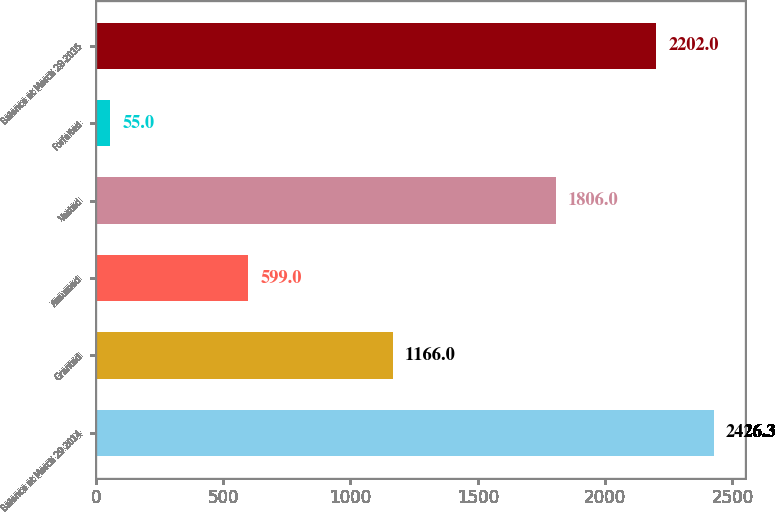Convert chart to OTSL. <chart><loc_0><loc_0><loc_500><loc_500><bar_chart><fcel>Balance at March 29 2014<fcel>Granted<fcel>Assumed<fcel>Vested<fcel>Forfeited<fcel>Balance at March 28 2015<nl><fcel>2426.3<fcel>1166<fcel>599<fcel>1806<fcel>55<fcel>2202<nl></chart> 